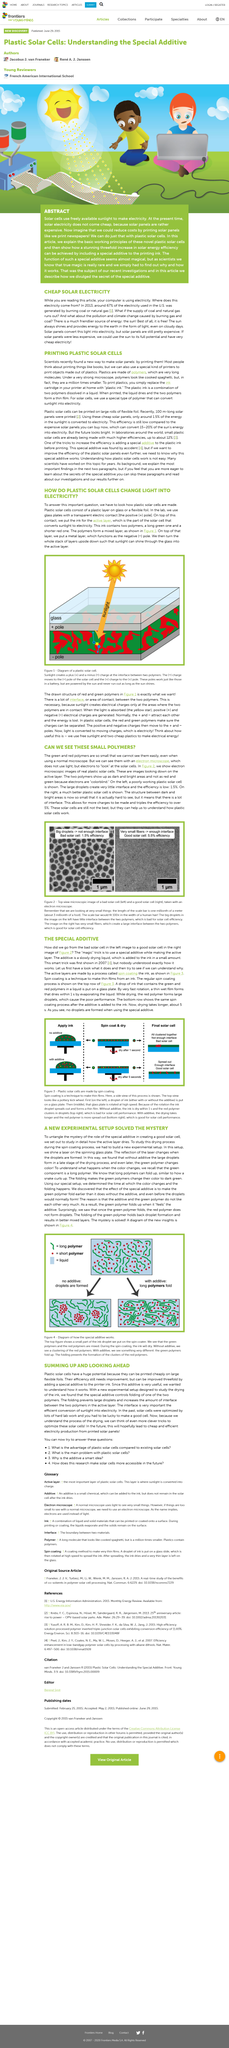Indicate a few pertinent items in this graphic. The scale bar measures one millionth of a meter, according to the declaration. The use of a special additive in spin coating was first demonstrated in 2007, resulting in the magical trick of creating high-quality films. The topmost layer of a multilayer ceramic capacitor is typically a metal layer that is deposited on top of the active layer. The ink contains two polymers. An electron microscope uses electrons to observe cells instead of light. 